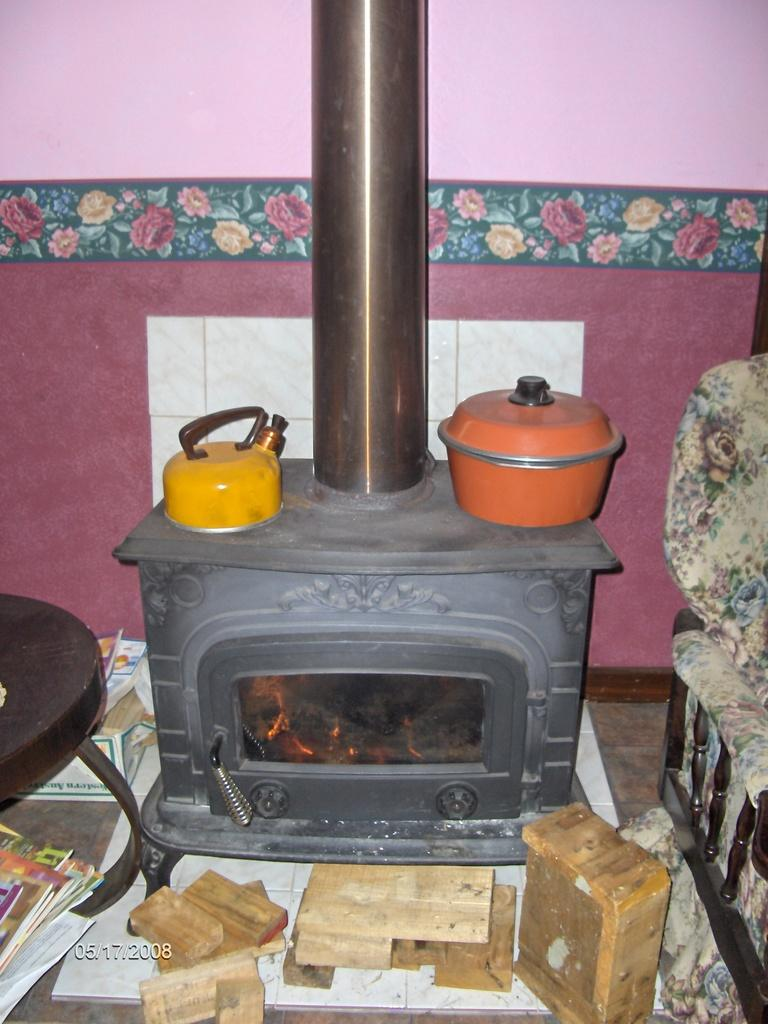What is the main object in the image? There is a kettle in the image. What other objects can be seen in the image? There is a vessel, a chimney, a campfire, wooden blocks, and a sofa set visible in the image. What type of structure is visible in the background of the image? There is a wall visible in the background of the image. What is the position of the toad in the image? There is no toad present in the image. What scent can be detected from the campfire in the image? The image does not provide information about the scent of the campfire. 